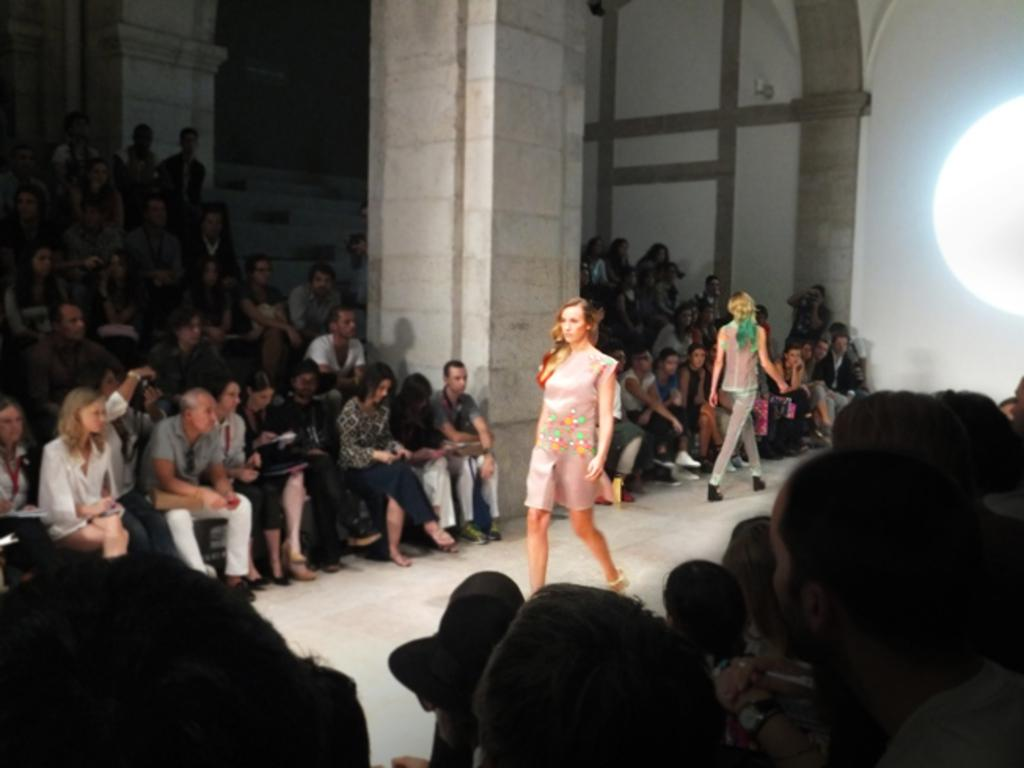What are the ladies in the image doing? The ladies in the image are walking. What feature is present in the image that might aid in accessibility? There is a ramp in the image. What can be seen in the image that indicates a gathering of people? There is a crowd sitting in the image. What architectural element is present in the image? There is a pillar in the image. What is the source of light on the right side of the image? There is a light on the right side of the image. What is visible in the background of the image? There is a wall in the background of the image. What type of cakes are being served to the bees in the image? There are no bees or cakes present in the image. What verse is being recited by the crowd in the image? There is no verse being recited by the crowd in the image. 